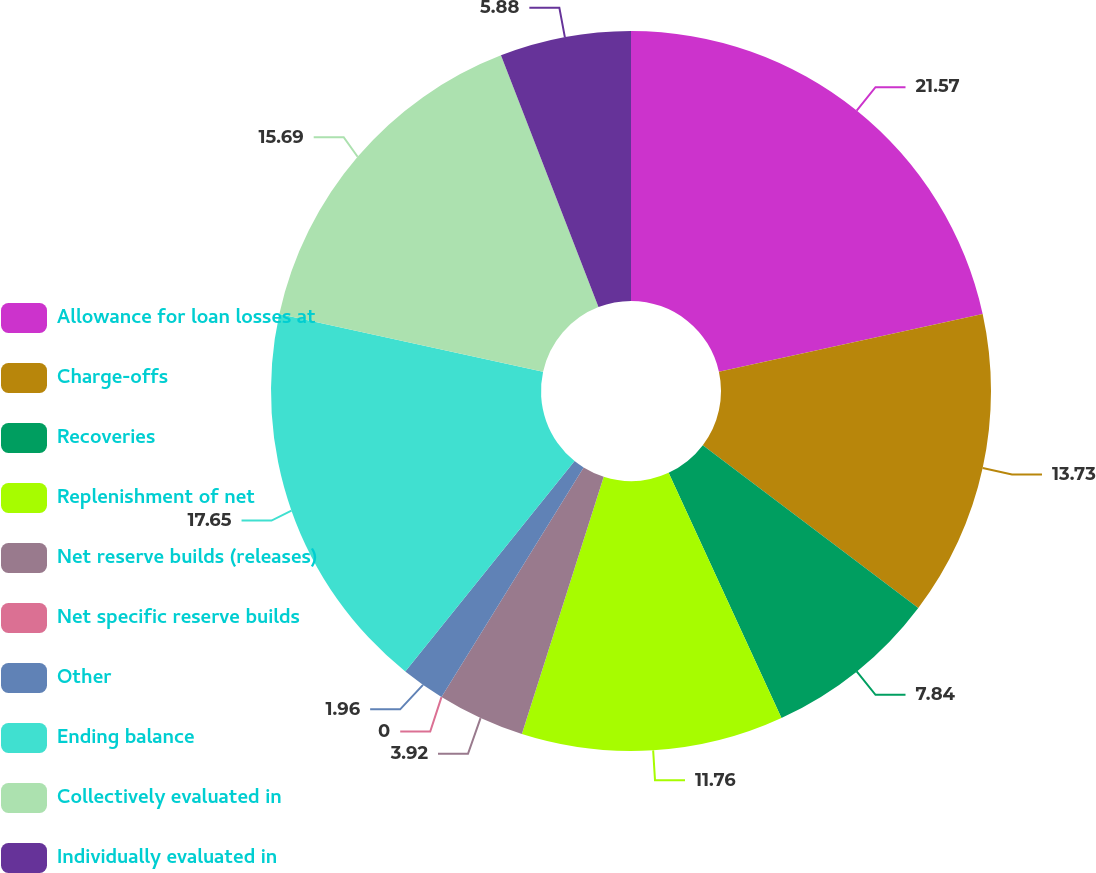Convert chart to OTSL. <chart><loc_0><loc_0><loc_500><loc_500><pie_chart><fcel>Allowance for loan losses at<fcel>Charge-offs<fcel>Recoveries<fcel>Replenishment of net<fcel>Net reserve builds (releases)<fcel>Net specific reserve builds<fcel>Other<fcel>Ending balance<fcel>Collectively evaluated in<fcel>Individually evaluated in<nl><fcel>21.56%<fcel>13.72%<fcel>7.84%<fcel>11.76%<fcel>3.92%<fcel>0.0%<fcel>1.96%<fcel>17.64%<fcel>15.68%<fcel>5.88%<nl></chart> 